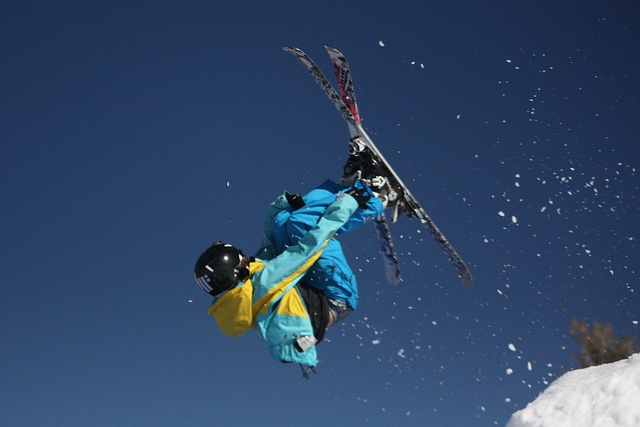Describe the objects in this image and their specific colors. I can see people in navy, black, blue, and teal tones and skis in navy, gray, black, and darkblue tones in this image. 